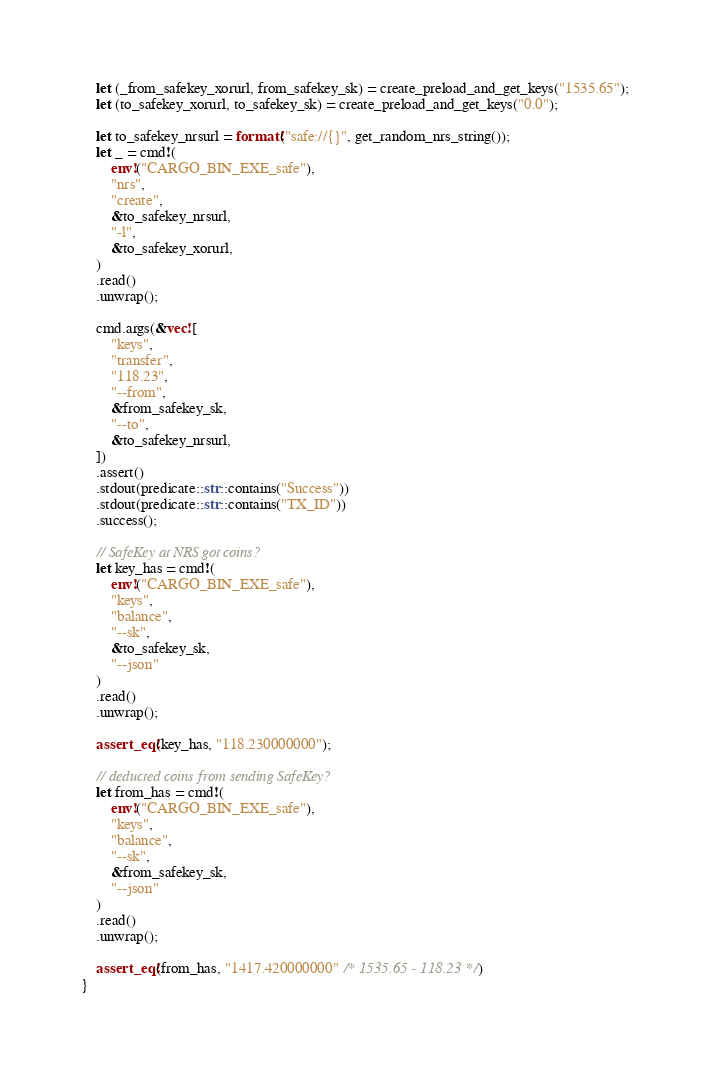Convert code to text. <code><loc_0><loc_0><loc_500><loc_500><_Rust_>    let (_from_safekey_xorurl, from_safekey_sk) = create_preload_and_get_keys("1535.65");
    let (to_safekey_xorurl, to_safekey_sk) = create_preload_and_get_keys("0.0");

    let to_safekey_nrsurl = format!("safe://{}", get_random_nrs_string());
    let _ = cmd!(
        env!("CARGO_BIN_EXE_safe"),
        "nrs",
        "create",
        &to_safekey_nrsurl,
        "-l",
        &to_safekey_xorurl,
    )
    .read()
    .unwrap();

    cmd.args(&vec![
        "keys",
        "transfer",
        "118.23",
        "--from",
        &from_safekey_sk,
        "--to",
        &to_safekey_nrsurl,
    ])
    .assert()
    .stdout(predicate::str::contains("Success"))
    .stdout(predicate::str::contains("TX_ID"))
    .success();

    // SafeKey at NRS got coins?
    let key_has = cmd!(
        env!("CARGO_BIN_EXE_safe"),
        "keys",
        "balance",
        "--sk",
        &to_safekey_sk,
        "--json"
    )
    .read()
    .unwrap();

    assert_eq!(key_has, "118.230000000");

    // deducted coins from sending SafeKey?
    let from_has = cmd!(
        env!("CARGO_BIN_EXE_safe"),
        "keys",
        "balance",
        "--sk",
        &from_safekey_sk,
        "--json"
    )
    .read()
    .unwrap();

    assert_eq!(from_has, "1417.420000000" /* 1535.65 - 118.23 */)
}
</code> 